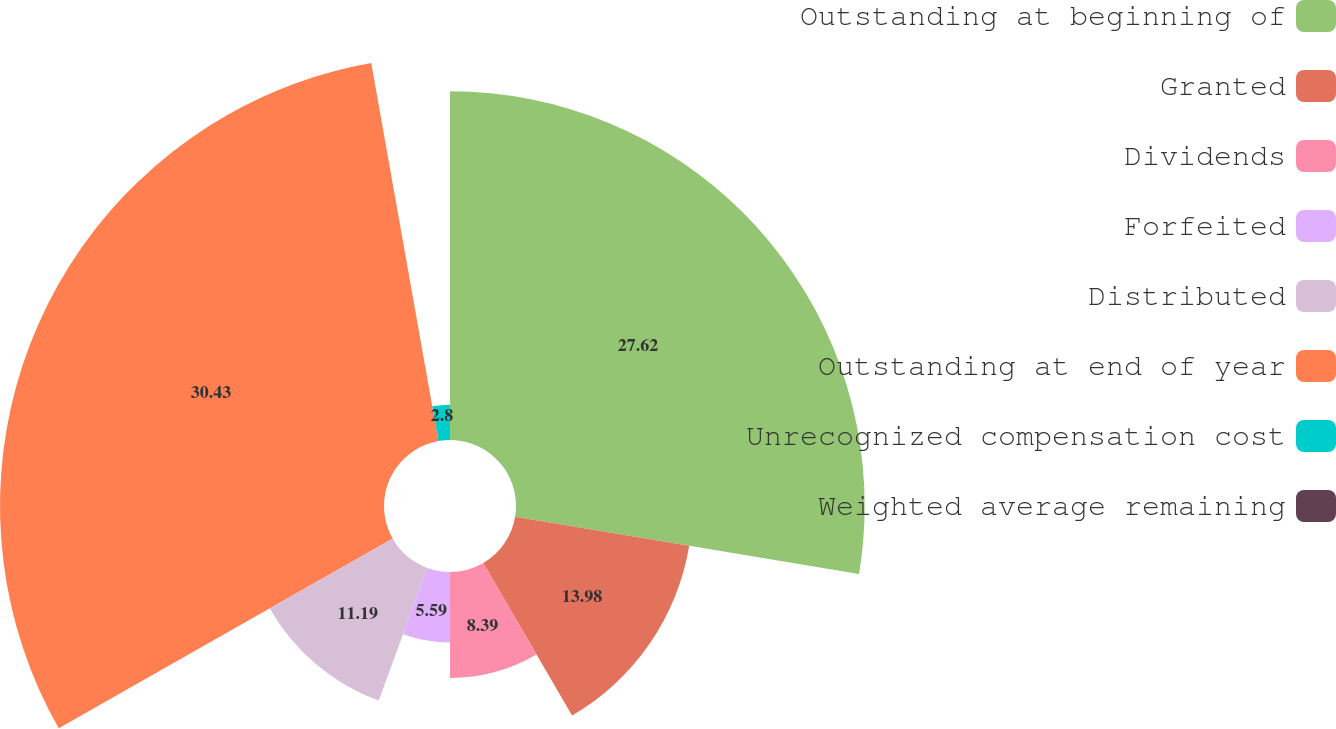Convert chart. <chart><loc_0><loc_0><loc_500><loc_500><pie_chart><fcel>Outstanding at beginning of<fcel>Granted<fcel>Dividends<fcel>Forfeited<fcel>Distributed<fcel>Outstanding at end of year<fcel>Unrecognized compensation cost<fcel>Weighted average remaining<nl><fcel>27.62%<fcel>13.98%<fcel>8.39%<fcel>5.59%<fcel>11.19%<fcel>30.42%<fcel>2.8%<fcel>0.0%<nl></chart> 